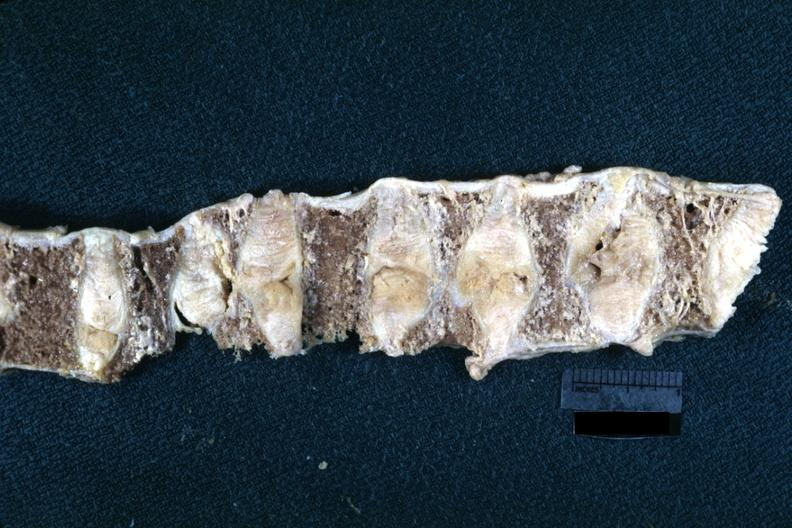does this image show fixed tissue lateral view of vertebral bodies with many collapsed case of rheumatoid arthritis?
Answer the question using a single word or phrase. Yes 